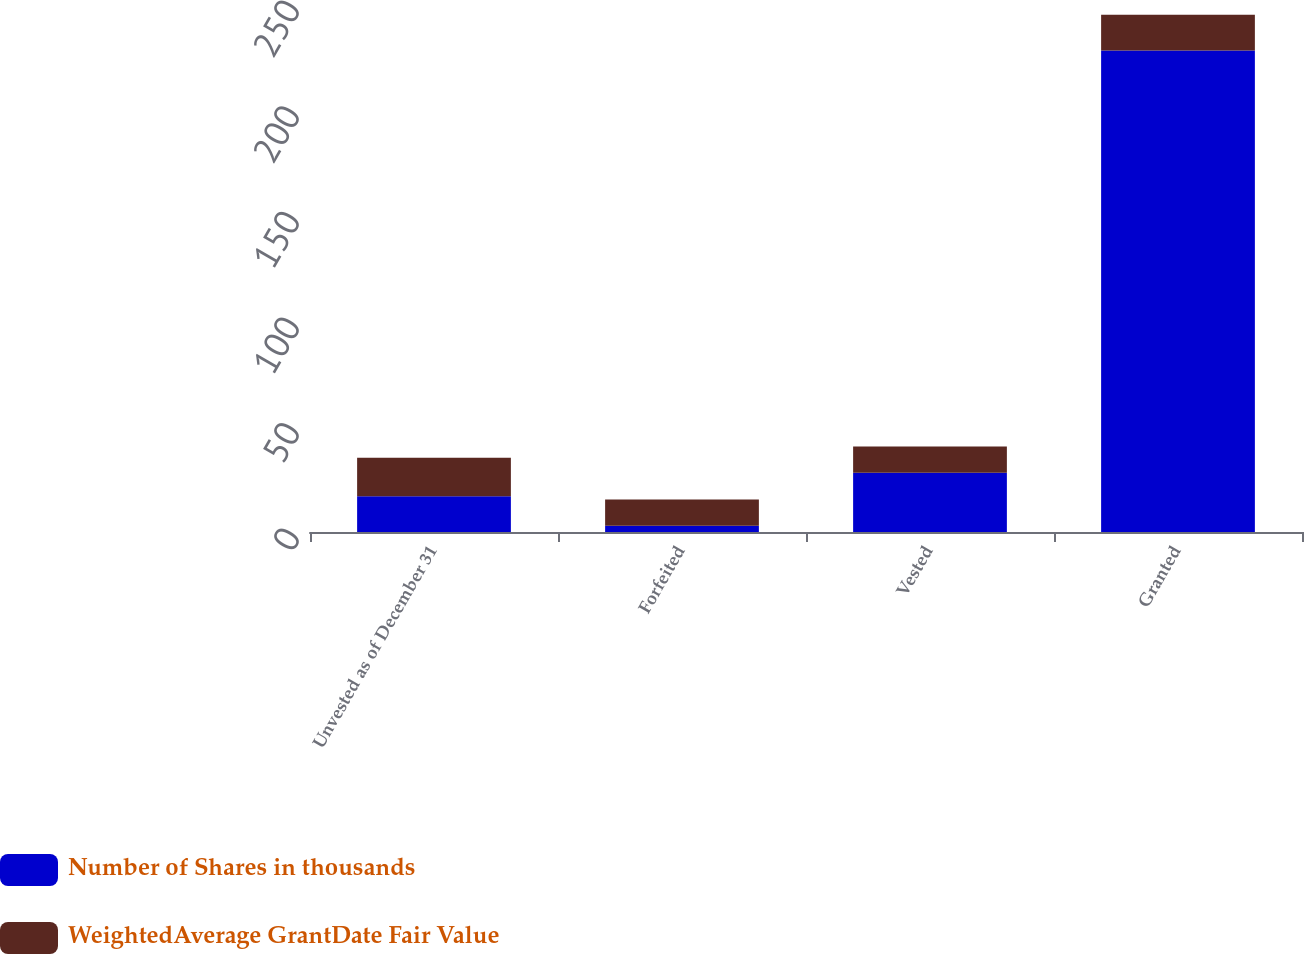<chart> <loc_0><loc_0><loc_500><loc_500><stacked_bar_chart><ecel><fcel>Unvested as of December 31<fcel>Forfeited<fcel>Vested<fcel>Granted<nl><fcel>Number of Shares in thousands<fcel>16.9<fcel>3<fcel>28<fcel>228<nl><fcel>WeightedAverage GrantDate Fair Value<fcel>18.26<fcel>12.43<fcel>12.5<fcel>16.9<nl></chart> 